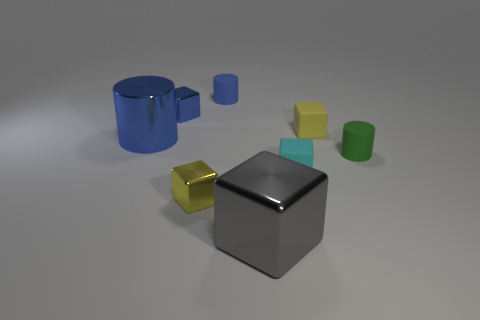Subtract all tiny green rubber cylinders. How many cylinders are left? 2 Subtract all blue cubes. How many cubes are left? 4 Subtract 1 cylinders. How many cylinders are left? 2 Add 2 cyan blocks. How many objects exist? 10 Subtract all cylinders. How many objects are left? 5 Subtract all large brown rubber cylinders. Subtract all cubes. How many objects are left? 3 Add 3 large gray things. How many large gray things are left? 4 Add 7 big blocks. How many big blocks exist? 8 Subtract 2 yellow blocks. How many objects are left? 6 Subtract all gray cylinders. Subtract all brown spheres. How many cylinders are left? 3 